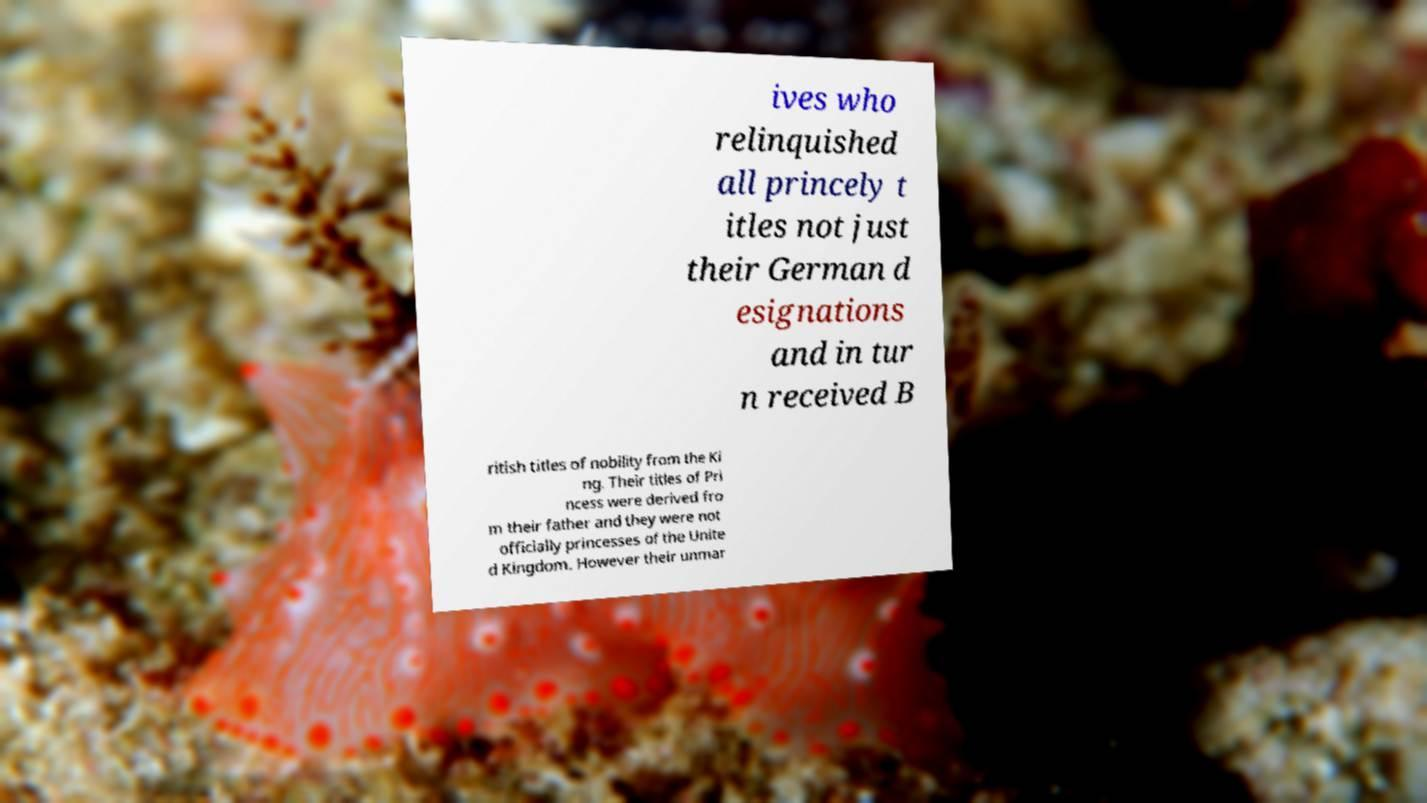Can you accurately transcribe the text from the provided image for me? ives who relinquished all princely t itles not just their German d esignations and in tur n received B ritish titles of nobility from the Ki ng. Their titles of Pri ncess were derived fro m their father and they were not officially princesses of the Unite d Kingdom. However their unmar 